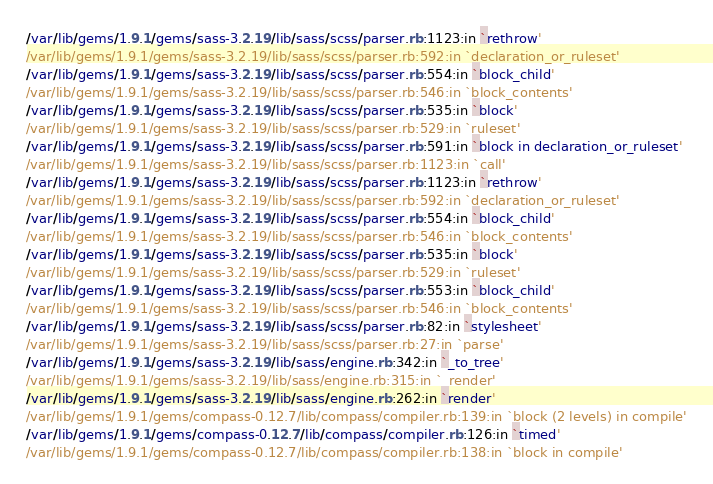Convert code to text. <code><loc_0><loc_0><loc_500><loc_500><_CSS_>/var/lib/gems/1.9.1/gems/sass-3.2.19/lib/sass/scss/parser.rb:1123:in `rethrow'
/var/lib/gems/1.9.1/gems/sass-3.2.19/lib/sass/scss/parser.rb:592:in `declaration_or_ruleset'
/var/lib/gems/1.9.1/gems/sass-3.2.19/lib/sass/scss/parser.rb:554:in `block_child'
/var/lib/gems/1.9.1/gems/sass-3.2.19/lib/sass/scss/parser.rb:546:in `block_contents'
/var/lib/gems/1.9.1/gems/sass-3.2.19/lib/sass/scss/parser.rb:535:in `block'
/var/lib/gems/1.9.1/gems/sass-3.2.19/lib/sass/scss/parser.rb:529:in `ruleset'
/var/lib/gems/1.9.1/gems/sass-3.2.19/lib/sass/scss/parser.rb:591:in `block in declaration_or_ruleset'
/var/lib/gems/1.9.1/gems/sass-3.2.19/lib/sass/scss/parser.rb:1123:in `call'
/var/lib/gems/1.9.1/gems/sass-3.2.19/lib/sass/scss/parser.rb:1123:in `rethrow'
/var/lib/gems/1.9.1/gems/sass-3.2.19/lib/sass/scss/parser.rb:592:in `declaration_or_ruleset'
/var/lib/gems/1.9.1/gems/sass-3.2.19/lib/sass/scss/parser.rb:554:in `block_child'
/var/lib/gems/1.9.1/gems/sass-3.2.19/lib/sass/scss/parser.rb:546:in `block_contents'
/var/lib/gems/1.9.1/gems/sass-3.2.19/lib/sass/scss/parser.rb:535:in `block'
/var/lib/gems/1.9.1/gems/sass-3.2.19/lib/sass/scss/parser.rb:529:in `ruleset'
/var/lib/gems/1.9.1/gems/sass-3.2.19/lib/sass/scss/parser.rb:553:in `block_child'
/var/lib/gems/1.9.1/gems/sass-3.2.19/lib/sass/scss/parser.rb:546:in `block_contents'
/var/lib/gems/1.9.1/gems/sass-3.2.19/lib/sass/scss/parser.rb:82:in `stylesheet'
/var/lib/gems/1.9.1/gems/sass-3.2.19/lib/sass/scss/parser.rb:27:in `parse'
/var/lib/gems/1.9.1/gems/sass-3.2.19/lib/sass/engine.rb:342:in `_to_tree'
/var/lib/gems/1.9.1/gems/sass-3.2.19/lib/sass/engine.rb:315:in `_render'
/var/lib/gems/1.9.1/gems/sass-3.2.19/lib/sass/engine.rb:262:in `render'
/var/lib/gems/1.9.1/gems/compass-0.12.7/lib/compass/compiler.rb:139:in `block (2 levels) in compile'
/var/lib/gems/1.9.1/gems/compass-0.12.7/lib/compass/compiler.rb:126:in `timed'
/var/lib/gems/1.9.1/gems/compass-0.12.7/lib/compass/compiler.rb:138:in `block in compile'</code> 